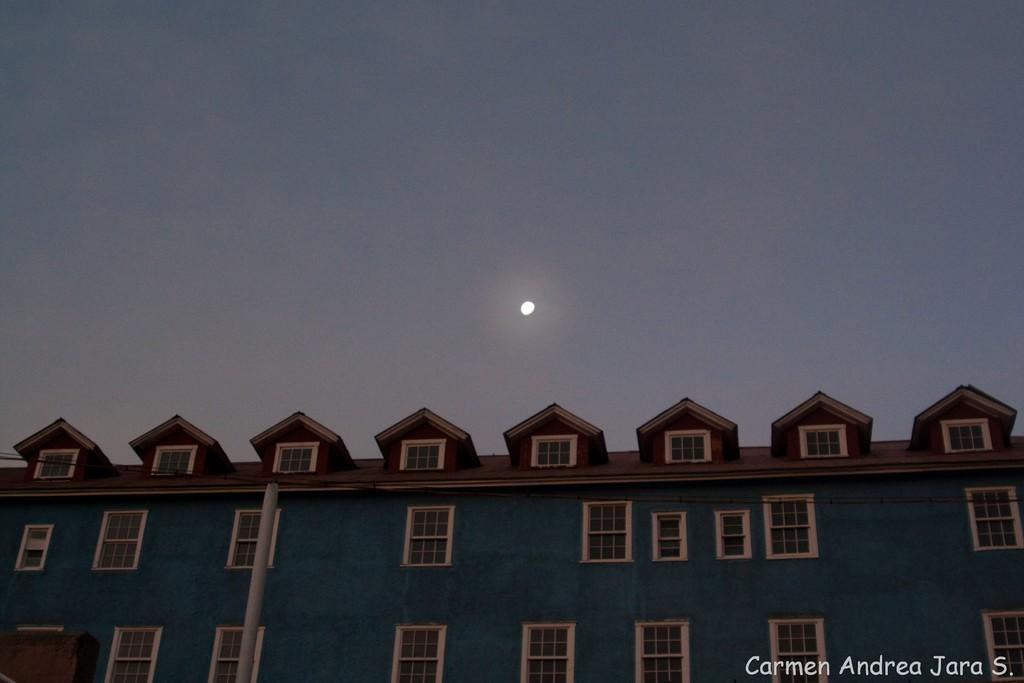What type of structure is located at the bottom of the picture? There is a building at the bottom of the picture. What is the color of the building? The building is blue in color. What features can be seen on the building? There are windows and a door on the building. What else is present in the picture besides the building? There is a pole in the picture. What is visible at the top of the picture? The sky is visible at the top of the picture, and the moon is visible in the sky. How many pancakes are stacked on the pole in the picture? There are no pancakes present in the image; the pole is not related to pancakes. What type of rat can be seen climbing the building in the picture? There are no rats present in the image; the building does not have any rats climbing it. 